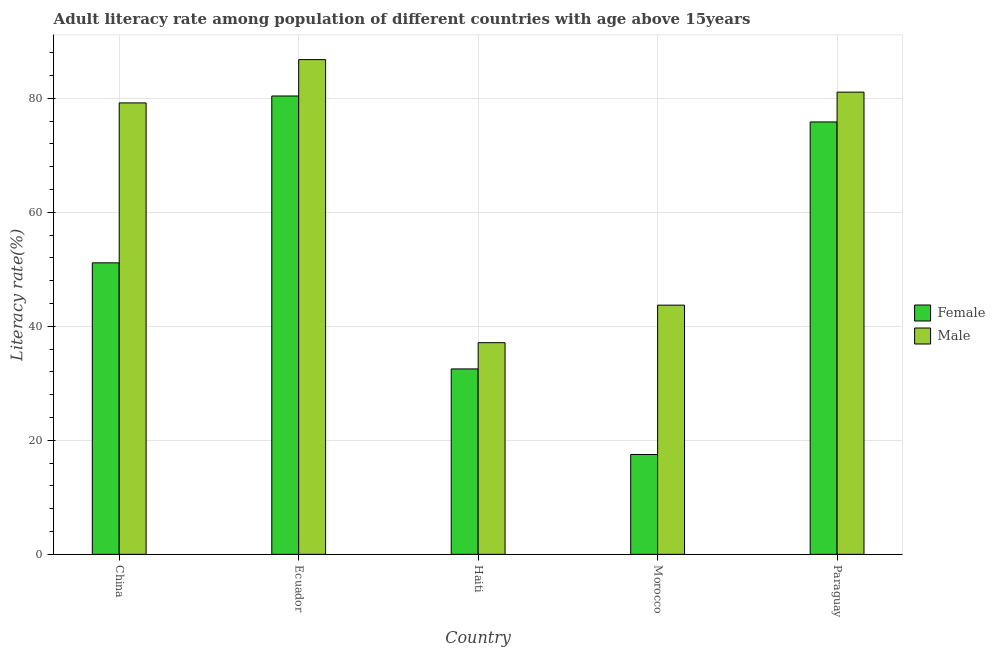How many different coloured bars are there?
Make the answer very short. 2. How many groups of bars are there?
Keep it short and to the point. 5. Are the number of bars per tick equal to the number of legend labels?
Your answer should be very brief. Yes. How many bars are there on the 2nd tick from the left?
Provide a succinct answer. 2. How many bars are there on the 3rd tick from the right?
Provide a short and direct response. 2. What is the label of the 2nd group of bars from the left?
Your answer should be very brief. Ecuador. In how many cases, is the number of bars for a given country not equal to the number of legend labels?
Your answer should be very brief. 0. What is the male adult literacy rate in China?
Give a very brief answer. 79.19. Across all countries, what is the maximum male adult literacy rate?
Keep it short and to the point. 86.79. Across all countries, what is the minimum female adult literacy rate?
Offer a terse response. 17.51. In which country was the male adult literacy rate maximum?
Your response must be concise. Ecuador. In which country was the male adult literacy rate minimum?
Keep it short and to the point. Haiti. What is the total female adult literacy rate in the graph?
Ensure brevity in your answer.  257.43. What is the difference between the male adult literacy rate in Ecuador and that in Paraguay?
Ensure brevity in your answer.  5.7. What is the difference between the female adult literacy rate in Paraguay and the male adult literacy rate in Haiti?
Your response must be concise. 38.72. What is the average female adult literacy rate per country?
Give a very brief answer. 51.49. What is the difference between the female adult literacy rate and male adult literacy rate in Paraguay?
Give a very brief answer. -5.23. What is the ratio of the female adult literacy rate in China to that in Paraguay?
Offer a terse response. 0.67. What is the difference between the highest and the second highest female adult literacy rate?
Your response must be concise. 4.55. What is the difference between the highest and the lowest female adult literacy rate?
Your answer should be very brief. 62.89. What does the 2nd bar from the left in Paraguay represents?
Your answer should be compact. Male. What does the 1st bar from the right in Ecuador represents?
Make the answer very short. Male. How many bars are there?
Make the answer very short. 10. How many countries are there in the graph?
Your answer should be compact. 5. What is the difference between two consecutive major ticks on the Y-axis?
Offer a terse response. 20. Are the values on the major ticks of Y-axis written in scientific E-notation?
Give a very brief answer. No. Does the graph contain grids?
Your response must be concise. Yes. Where does the legend appear in the graph?
Your response must be concise. Center right. How are the legend labels stacked?
Provide a succinct answer. Vertical. What is the title of the graph?
Ensure brevity in your answer.  Adult literacy rate among population of different countries with age above 15years. Does "Attending school" appear as one of the legend labels in the graph?
Provide a short and direct response. No. What is the label or title of the Y-axis?
Offer a very short reply. Literacy rate(%). What is the Literacy rate(%) of Female in China?
Offer a terse response. 51.14. What is the Literacy rate(%) in Male in China?
Your response must be concise. 79.19. What is the Literacy rate(%) of Female in Ecuador?
Give a very brief answer. 80.41. What is the Literacy rate(%) in Male in Ecuador?
Give a very brief answer. 86.79. What is the Literacy rate(%) in Female in Haiti?
Provide a short and direct response. 32.52. What is the Literacy rate(%) in Male in Haiti?
Offer a terse response. 37.13. What is the Literacy rate(%) in Female in Morocco?
Your answer should be compact. 17.51. What is the Literacy rate(%) in Male in Morocco?
Your answer should be very brief. 43.71. What is the Literacy rate(%) in Female in Paraguay?
Give a very brief answer. 75.85. What is the Literacy rate(%) in Male in Paraguay?
Keep it short and to the point. 81.08. Across all countries, what is the maximum Literacy rate(%) of Female?
Give a very brief answer. 80.41. Across all countries, what is the maximum Literacy rate(%) of Male?
Offer a very short reply. 86.79. Across all countries, what is the minimum Literacy rate(%) of Female?
Your answer should be compact. 17.51. Across all countries, what is the minimum Literacy rate(%) of Male?
Your response must be concise. 37.13. What is the total Literacy rate(%) in Female in the graph?
Ensure brevity in your answer.  257.43. What is the total Literacy rate(%) of Male in the graph?
Keep it short and to the point. 327.91. What is the difference between the Literacy rate(%) of Female in China and that in Ecuador?
Offer a very short reply. -29.27. What is the difference between the Literacy rate(%) of Male in China and that in Ecuador?
Keep it short and to the point. -7.6. What is the difference between the Literacy rate(%) of Female in China and that in Haiti?
Keep it short and to the point. 18.61. What is the difference between the Literacy rate(%) of Male in China and that in Haiti?
Your response must be concise. 42.06. What is the difference between the Literacy rate(%) of Female in China and that in Morocco?
Give a very brief answer. 33.62. What is the difference between the Literacy rate(%) in Male in China and that in Morocco?
Offer a very short reply. 35.48. What is the difference between the Literacy rate(%) of Female in China and that in Paraguay?
Offer a terse response. -24.72. What is the difference between the Literacy rate(%) in Male in China and that in Paraguay?
Provide a succinct answer. -1.89. What is the difference between the Literacy rate(%) of Female in Ecuador and that in Haiti?
Offer a very short reply. 47.88. What is the difference between the Literacy rate(%) in Male in Ecuador and that in Haiti?
Give a very brief answer. 49.66. What is the difference between the Literacy rate(%) of Female in Ecuador and that in Morocco?
Your answer should be compact. 62.89. What is the difference between the Literacy rate(%) in Male in Ecuador and that in Morocco?
Ensure brevity in your answer.  43.07. What is the difference between the Literacy rate(%) in Female in Ecuador and that in Paraguay?
Provide a short and direct response. 4.55. What is the difference between the Literacy rate(%) of Male in Ecuador and that in Paraguay?
Provide a succinct answer. 5.7. What is the difference between the Literacy rate(%) of Female in Haiti and that in Morocco?
Provide a short and direct response. 15.01. What is the difference between the Literacy rate(%) in Male in Haiti and that in Morocco?
Your answer should be compact. -6.58. What is the difference between the Literacy rate(%) of Female in Haiti and that in Paraguay?
Make the answer very short. -43.33. What is the difference between the Literacy rate(%) in Male in Haiti and that in Paraguay?
Offer a terse response. -43.95. What is the difference between the Literacy rate(%) in Female in Morocco and that in Paraguay?
Offer a very short reply. -58.34. What is the difference between the Literacy rate(%) in Male in Morocco and that in Paraguay?
Your response must be concise. -37.37. What is the difference between the Literacy rate(%) in Female in China and the Literacy rate(%) in Male in Ecuador?
Your answer should be compact. -35.65. What is the difference between the Literacy rate(%) of Female in China and the Literacy rate(%) of Male in Haiti?
Give a very brief answer. 14.01. What is the difference between the Literacy rate(%) of Female in China and the Literacy rate(%) of Male in Morocco?
Provide a succinct answer. 7.42. What is the difference between the Literacy rate(%) of Female in China and the Literacy rate(%) of Male in Paraguay?
Your answer should be compact. -29.95. What is the difference between the Literacy rate(%) of Female in Ecuador and the Literacy rate(%) of Male in Haiti?
Provide a short and direct response. 43.28. What is the difference between the Literacy rate(%) in Female in Ecuador and the Literacy rate(%) in Male in Morocco?
Your answer should be very brief. 36.69. What is the difference between the Literacy rate(%) in Female in Ecuador and the Literacy rate(%) in Male in Paraguay?
Provide a succinct answer. -0.68. What is the difference between the Literacy rate(%) of Female in Haiti and the Literacy rate(%) of Male in Morocco?
Provide a succinct answer. -11.19. What is the difference between the Literacy rate(%) of Female in Haiti and the Literacy rate(%) of Male in Paraguay?
Your answer should be very brief. -48.56. What is the difference between the Literacy rate(%) of Female in Morocco and the Literacy rate(%) of Male in Paraguay?
Make the answer very short. -63.57. What is the average Literacy rate(%) in Female per country?
Provide a short and direct response. 51.49. What is the average Literacy rate(%) in Male per country?
Provide a short and direct response. 65.58. What is the difference between the Literacy rate(%) of Female and Literacy rate(%) of Male in China?
Provide a succinct answer. -28.05. What is the difference between the Literacy rate(%) of Female and Literacy rate(%) of Male in Ecuador?
Provide a short and direct response. -6.38. What is the difference between the Literacy rate(%) of Female and Literacy rate(%) of Male in Haiti?
Keep it short and to the point. -4.6. What is the difference between the Literacy rate(%) in Female and Literacy rate(%) in Male in Morocco?
Give a very brief answer. -26.2. What is the difference between the Literacy rate(%) of Female and Literacy rate(%) of Male in Paraguay?
Your answer should be very brief. -5.23. What is the ratio of the Literacy rate(%) of Female in China to that in Ecuador?
Your answer should be compact. 0.64. What is the ratio of the Literacy rate(%) in Male in China to that in Ecuador?
Provide a short and direct response. 0.91. What is the ratio of the Literacy rate(%) in Female in China to that in Haiti?
Offer a terse response. 1.57. What is the ratio of the Literacy rate(%) in Male in China to that in Haiti?
Provide a succinct answer. 2.13. What is the ratio of the Literacy rate(%) of Female in China to that in Morocco?
Your response must be concise. 2.92. What is the ratio of the Literacy rate(%) of Male in China to that in Morocco?
Give a very brief answer. 1.81. What is the ratio of the Literacy rate(%) of Female in China to that in Paraguay?
Offer a terse response. 0.67. What is the ratio of the Literacy rate(%) of Male in China to that in Paraguay?
Provide a succinct answer. 0.98. What is the ratio of the Literacy rate(%) of Female in Ecuador to that in Haiti?
Make the answer very short. 2.47. What is the ratio of the Literacy rate(%) of Male in Ecuador to that in Haiti?
Give a very brief answer. 2.34. What is the ratio of the Literacy rate(%) in Female in Ecuador to that in Morocco?
Your response must be concise. 4.59. What is the ratio of the Literacy rate(%) in Male in Ecuador to that in Morocco?
Make the answer very short. 1.99. What is the ratio of the Literacy rate(%) of Female in Ecuador to that in Paraguay?
Ensure brevity in your answer.  1.06. What is the ratio of the Literacy rate(%) of Male in Ecuador to that in Paraguay?
Offer a terse response. 1.07. What is the ratio of the Literacy rate(%) of Female in Haiti to that in Morocco?
Your response must be concise. 1.86. What is the ratio of the Literacy rate(%) in Male in Haiti to that in Morocco?
Provide a short and direct response. 0.85. What is the ratio of the Literacy rate(%) in Female in Haiti to that in Paraguay?
Your answer should be compact. 0.43. What is the ratio of the Literacy rate(%) of Male in Haiti to that in Paraguay?
Ensure brevity in your answer.  0.46. What is the ratio of the Literacy rate(%) in Female in Morocco to that in Paraguay?
Give a very brief answer. 0.23. What is the ratio of the Literacy rate(%) in Male in Morocco to that in Paraguay?
Make the answer very short. 0.54. What is the difference between the highest and the second highest Literacy rate(%) in Female?
Provide a short and direct response. 4.55. What is the difference between the highest and the second highest Literacy rate(%) in Male?
Your response must be concise. 5.7. What is the difference between the highest and the lowest Literacy rate(%) in Female?
Ensure brevity in your answer.  62.89. What is the difference between the highest and the lowest Literacy rate(%) of Male?
Offer a very short reply. 49.66. 